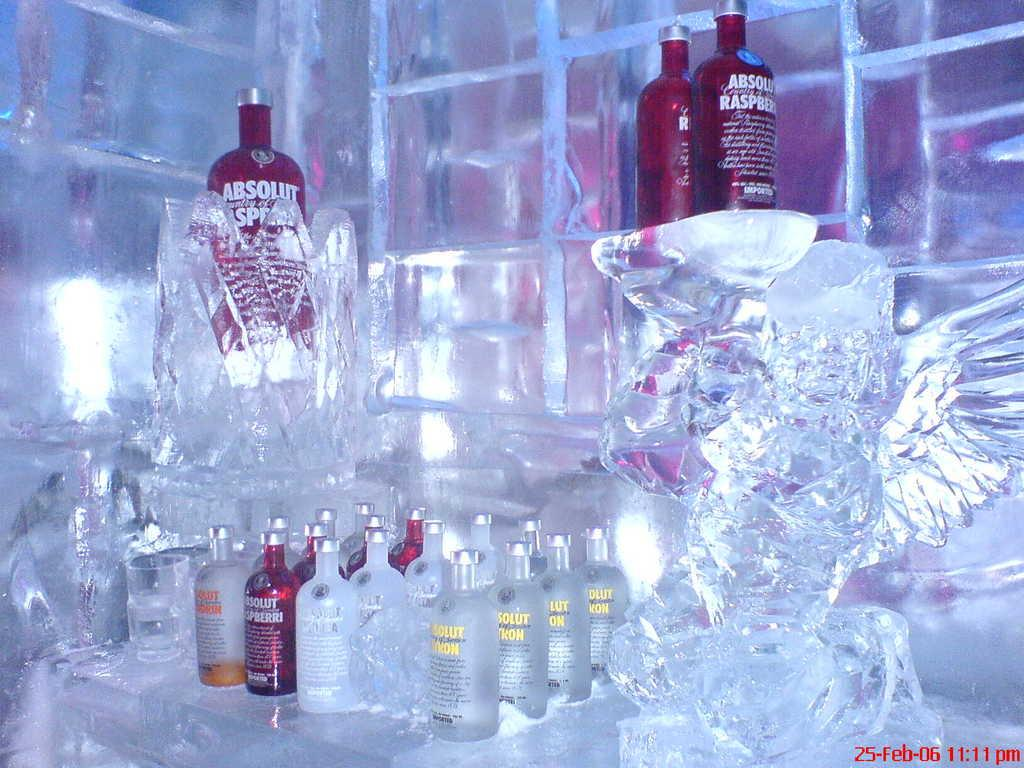<image>
Render a clear and concise summary of the photo. A picture of an ice sculpture and several bottles of vodka that was taken on February 25, 2006. 